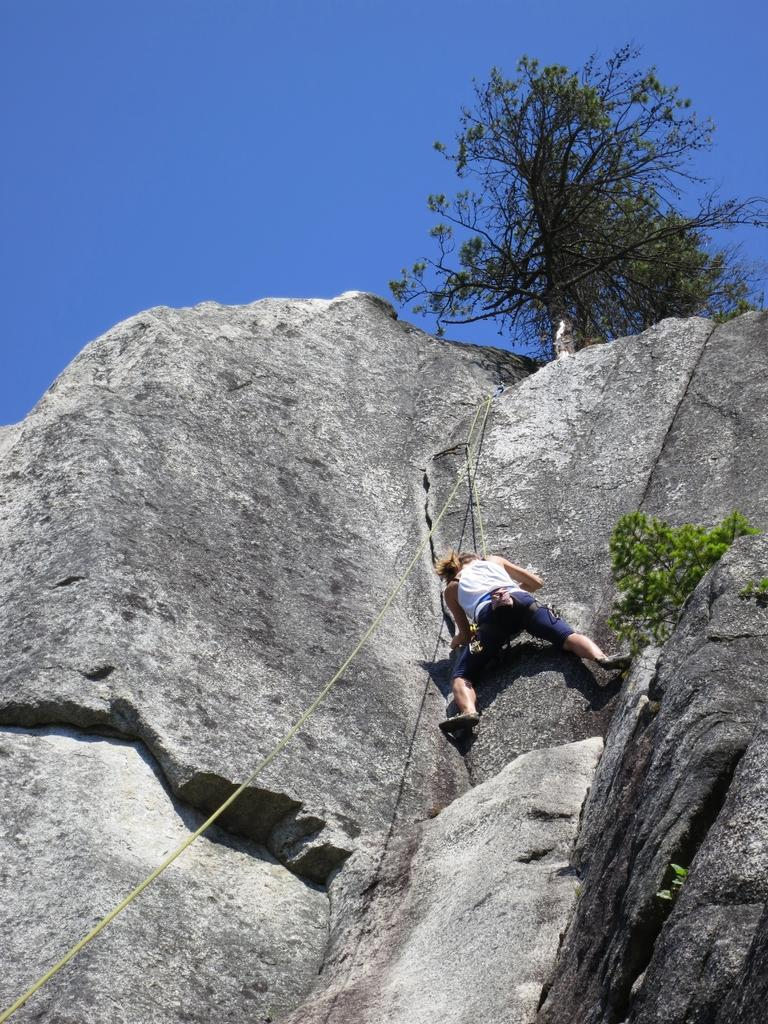Who is the main subject in the image? There is a woman in the image. What is the woman doing in the image? The woman is climbing a rock. How is the woman climbing the rock? The woman is using ropes for climbing. What can be seen at the top of the rock? There are trees at the top of the rock. What is the color of the sky in the image? The sky is blue. What type of insurance does the woman have for her climbing activity? There is no information about insurance in the image, nor is there any indication of the woman's insurance status. 